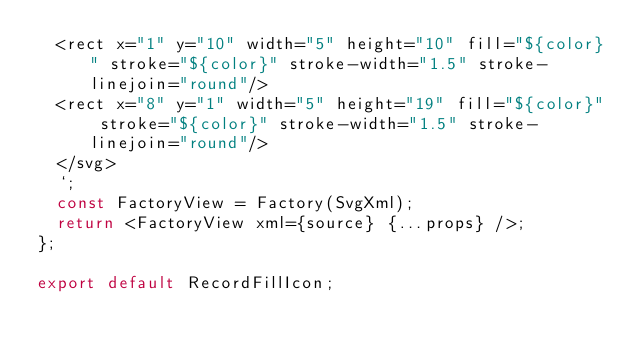<code> <loc_0><loc_0><loc_500><loc_500><_TypeScript_>  <rect x="1" y="10" width="5" height="10" fill="${color}" stroke="${color}" stroke-width="1.5" stroke-linejoin="round"/>
  <rect x="8" y="1" width="5" height="19" fill="${color}" stroke="${color}" stroke-width="1.5" stroke-linejoin="round"/>
  </svg>  
  `;
  const FactoryView = Factory(SvgXml);
  return <FactoryView xml={source} {...props} />;
};

export default RecordFillIcon;
</code> 